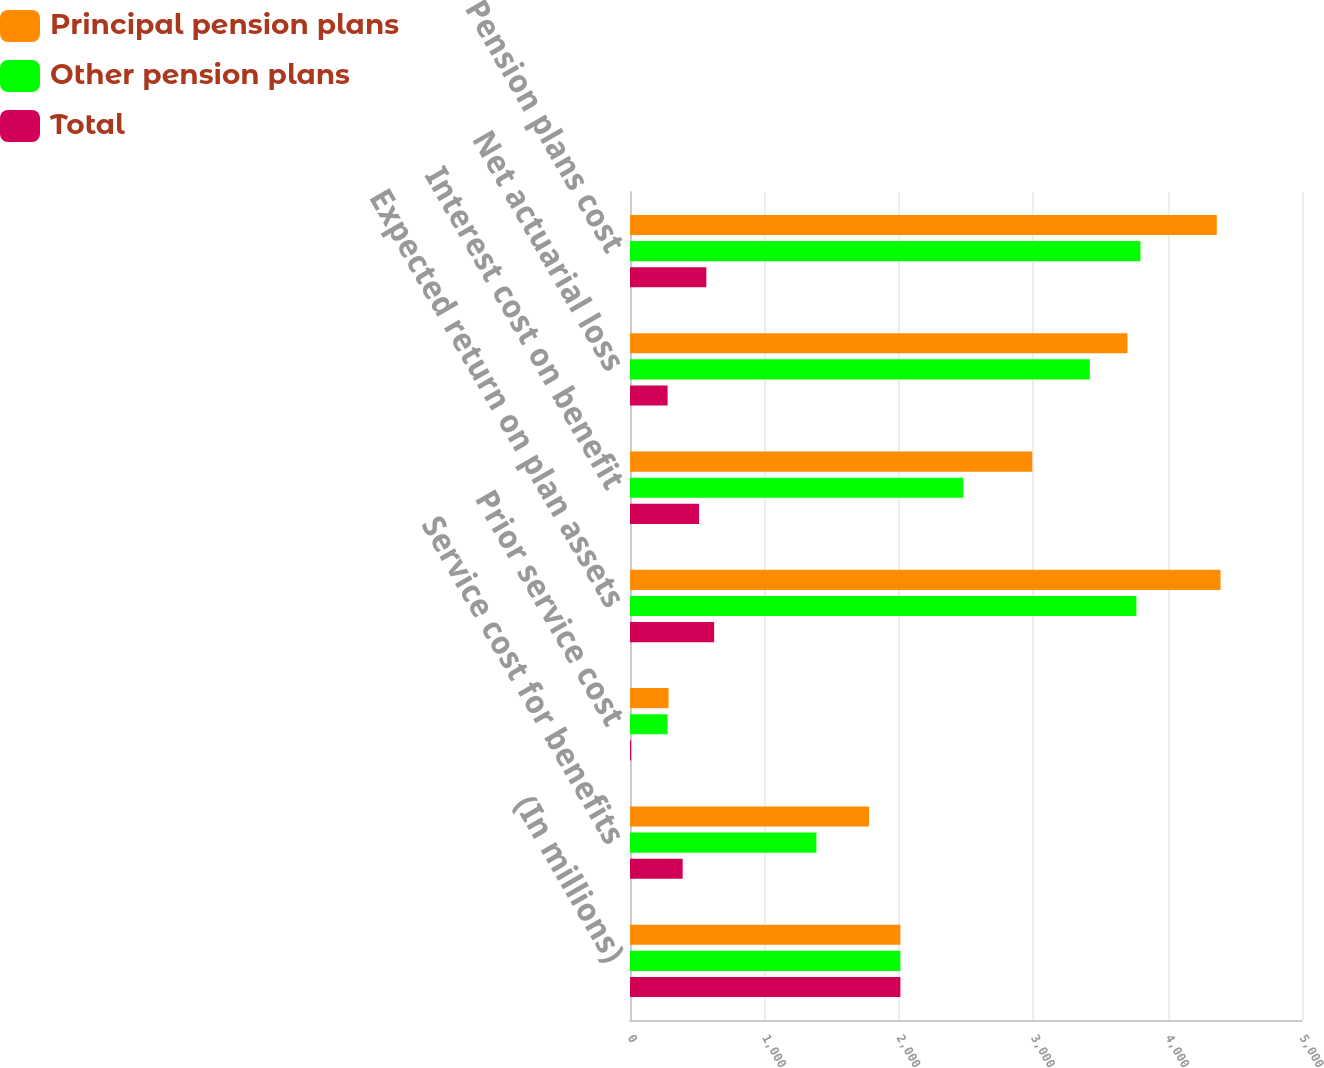<chart> <loc_0><loc_0><loc_500><loc_500><stacked_bar_chart><ecel><fcel>(In millions)<fcel>Service cost for benefits<fcel>Prior service cost<fcel>Expected return on plan assets<fcel>Interest cost on benefit<fcel>Net actuarial loss<fcel>Pension plans cost<nl><fcel>Principal pension plans<fcel>2012<fcel>1779<fcel>287<fcel>4394<fcel>2993<fcel>3701<fcel>4366<nl><fcel>Other pension plans<fcel>2012<fcel>1387<fcel>279<fcel>3768<fcel>2479<fcel>3421<fcel>3798<nl><fcel>Total<fcel>2012<fcel>392<fcel>8<fcel>626<fcel>514<fcel>280<fcel>568<nl></chart> 